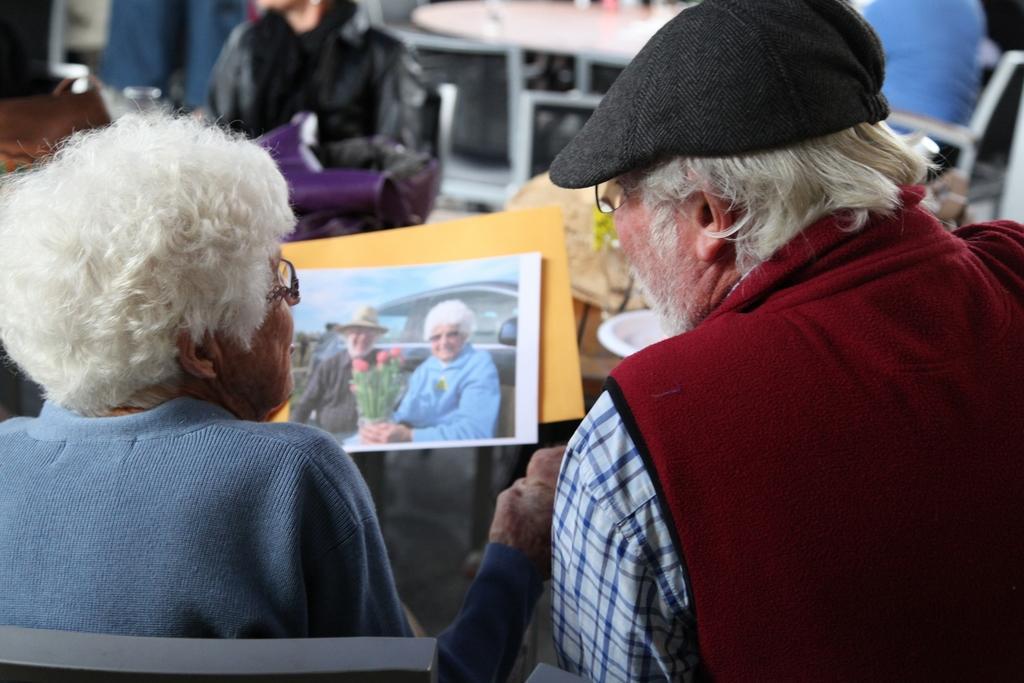How would you summarize this image in a sentence or two? In this picture there is an old woman sitting in chair and holding a photo graph in her hand and there is an old man sitting in chair beside her and there are few people,tables and some other objects in the background. 